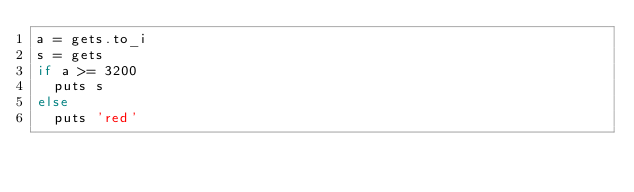<code> <loc_0><loc_0><loc_500><loc_500><_Ruby_>a = gets.to_i
s = gets
if a >= 3200
  puts s
else
  puts 'red'
</code> 